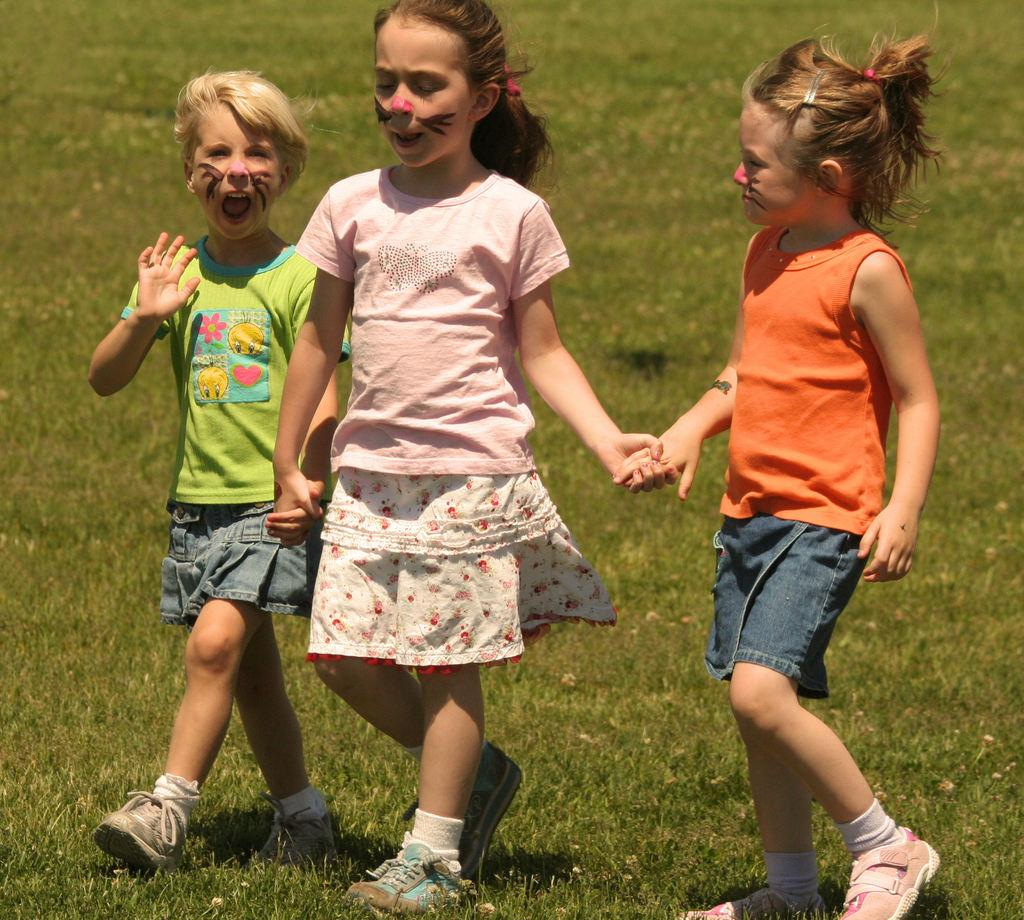What type of vegetation is present in the image? There is grass in the image. How many kids can be seen in the image? There are three kids in the image. What are the kids doing in the image? The kids are holding hands and walking together. What type of glue is being used by the kids in the image? There is no glue present in the image; the kids are holding hands and walking together. 